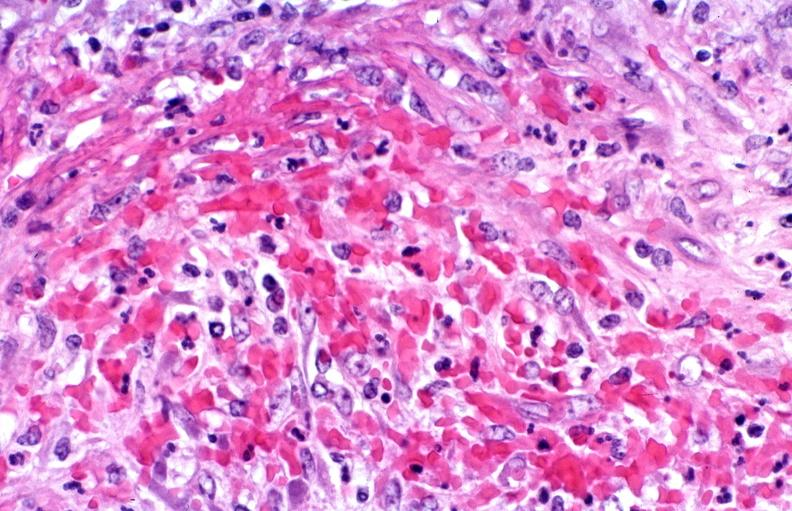s vasculature present?
Answer the question using a single word or phrase. Yes 